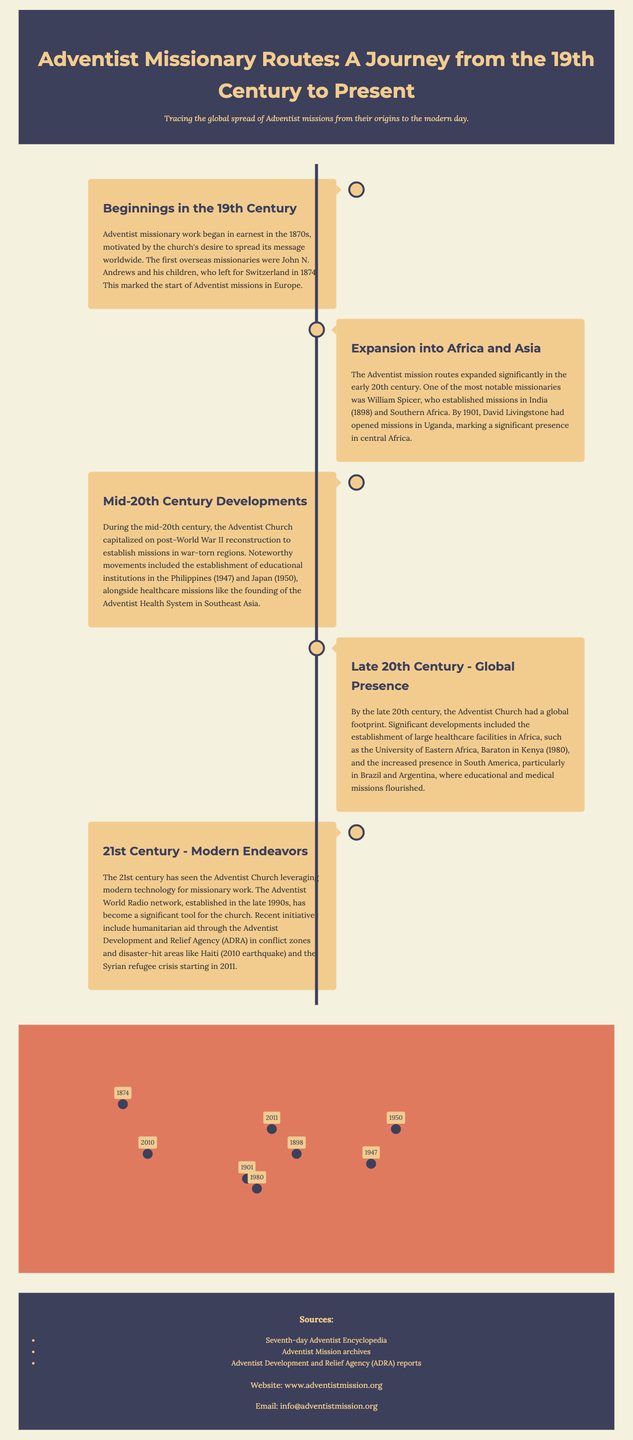What year did Adventist missionary work begin? The document states that Adventist missionary work began in earnest in the 1870s, specifically with the first overseas missionaries departing in 1874.
Answer: 1874 Who was the first overseas missionary to leave for Switzerland? The text identifies John N. Andrews and his children as the first overseas missionaries.
Answer: John N. Andrews Which continent saw significant Adventist mission routes expansion in the early 20th century? The document notes that the expansion into Africa and Asia occurred in the early 20th century.
Answer: Africa and Asia What major humanitarian aid efforts were made by ADRA in Haiti? The document mentions humanitarian aid provided following the 2010 earthquake in Haiti.
Answer: 2010 earthquake In which year was the University of Eastern Africa, Baraton established? The document specifies that the university was founded in 1980.
Answer: 1980 Which two countries saw educational missions established post-World War II? The document refers to the establishment of educational institutions in the Philippines and Japan.
Answer: Philippines and Japan What technological advancement has been utilized for missionary work in the 21st century? The document highlights that the Adventist World Radio network has been a significant tool for missionary work.
Answer: Adventist World Radio How are the Adventist missions documented geographically in this infographic? The infographic includes map markers that indicate various locations and events related to missionary activities.
Answer: Map markers What organization began humanitarian aid efforts during the Syrian refugee crisis? The document states that ADRA conducted humanitarian aid during the Syrian refugee crisis that started in 2011.
Answer: ADRA 